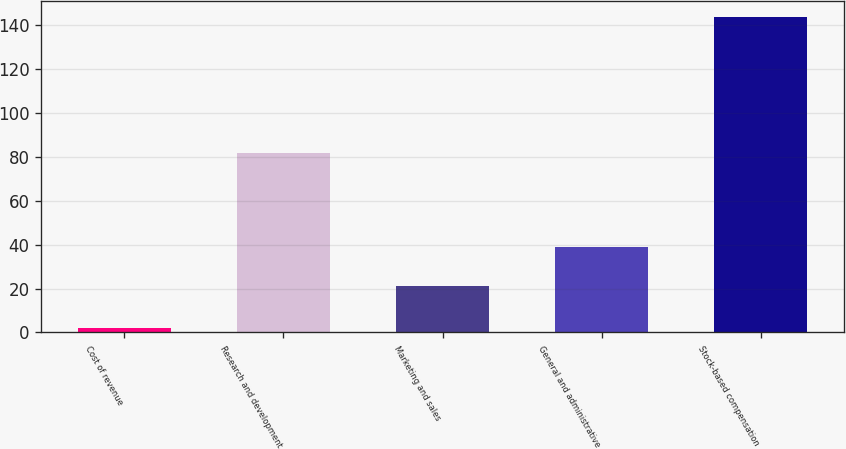<chart> <loc_0><loc_0><loc_500><loc_500><bar_chart><fcel>Cost of revenue<fcel>Research and development<fcel>Marketing and sales<fcel>General and administrative<fcel>Stock-based compensation<nl><fcel>2<fcel>82<fcel>21<fcel>39<fcel>144<nl></chart> 